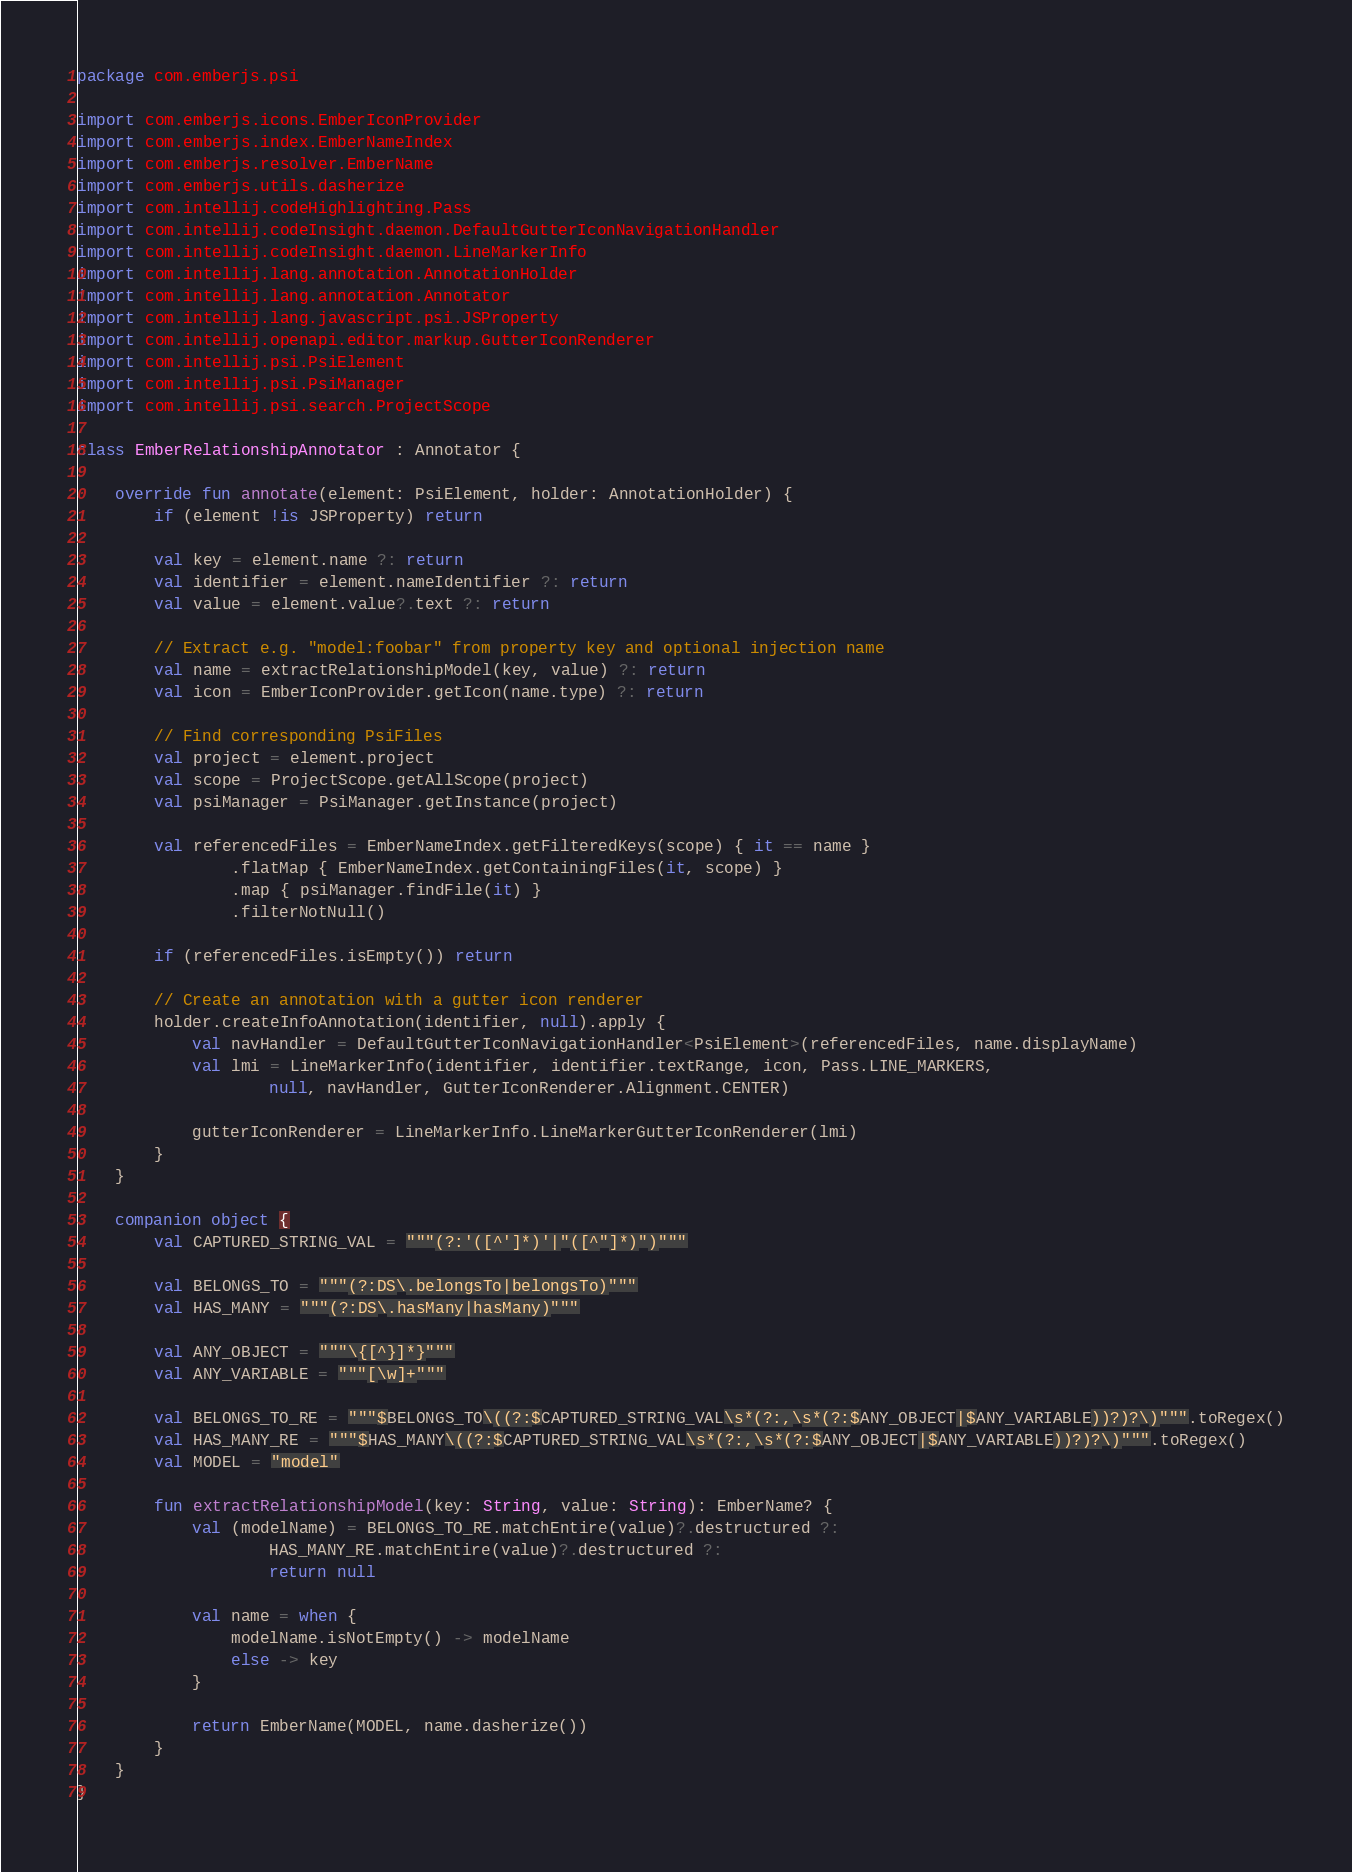Convert code to text. <code><loc_0><loc_0><loc_500><loc_500><_Kotlin_>package com.emberjs.psi

import com.emberjs.icons.EmberIconProvider
import com.emberjs.index.EmberNameIndex
import com.emberjs.resolver.EmberName
import com.emberjs.utils.dasherize
import com.intellij.codeHighlighting.Pass
import com.intellij.codeInsight.daemon.DefaultGutterIconNavigationHandler
import com.intellij.codeInsight.daemon.LineMarkerInfo
import com.intellij.lang.annotation.AnnotationHolder
import com.intellij.lang.annotation.Annotator
import com.intellij.lang.javascript.psi.JSProperty
import com.intellij.openapi.editor.markup.GutterIconRenderer
import com.intellij.psi.PsiElement
import com.intellij.psi.PsiManager
import com.intellij.psi.search.ProjectScope

class EmberRelationshipAnnotator : Annotator {

    override fun annotate(element: PsiElement, holder: AnnotationHolder) {
        if (element !is JSProperty) return

        val key = element.name ?: return
        val identifier = element.nameIdentifier ?: return
        val value = element.value?.text ?: return

        // Extract e.g. "model:foobar" from property key and optional injection name
        val name = extractRelationshipModel(key, value) ?: return
        val icon = EmberIconProvider.getIcon(name.type) ?: return

        // Find corresponding PsiFiles
        val project = element.project
        val scope = ProjectScope.getAllScope(project)
        val psiManager = PsiManager.getInstance(project)

        val referencedFiles = EmberNameIndex.getFilteredKeys(scope) { it == name }
                .flatMap { EmberNameIndex.getContainingFiles(it, scope) }
                .map { psiManager.findFile(it) }
                .filterNotNull()

        if (referencedFiles.isEmpty()) return

        // Create an annotation with a gutter icon renderer
        holder.createInfoAnnotation(identifier, null).apply {
            val navHandler = DefaultGutterIconNavigationHandler<PsiElement>(referencedFiles, name.displayName)
            val lmi = LineMarkerInfo(identifier, identifier.textRange, icon, Pass.LINE_MARKERS,
                    null, navHandler, GutterIconRenderer.Alignment.CENTER)

            gutterIconRenderer = LineMarkerInfo.LineMarkerGutterIconRenderer(lmi)
        }
    }

    companion object {
        val CAPTURED_STRING_VAL = """(?:'([^']*)'|"([^"]*)")"""

        val BELONGS_TO = """(?:DS\.belongsTo|belongsTo)"""
        val HAS_MANY = """(?:DS\.hasMany|hasMany)"""

        val ANY_OBJECT = """\{[^}]*}"""
        val ANY_VARIABLE = """[\w]+"""

        val BELONGS_TO_RE = """$BELONGS_TO\((?:$CAPTURED_STRING_VAL\s*(?:,\s*(?:$ANY_OBJECT|$ANY_VARIABLE))?)?\)""".toRegex()
        val HAS_MANY_RE = """$HAS_MANY\((?:$CAPTURED_STRING_VAL\s*(?:,\s*(?:$ANY_OBJECT|$ANY_VARIABLE))?)?\)""".toRegex()
        val MODEL = "model"

        fun extractRelationshipModel(key: String, value: String): EmberName? {
            val (modelName) = BELONGS_TO_RE.matchEntire(value)?.destructured ?:
                    HAS_MANY_RE.matchEntire(value)?.destructured ?:
                    return null

            val name = when {
                modelName.isNotEmpty() -> modelName
                else -> key
            }

            return EmberName(MODEL, name.dasherize())
        }
    }
}
</code> 